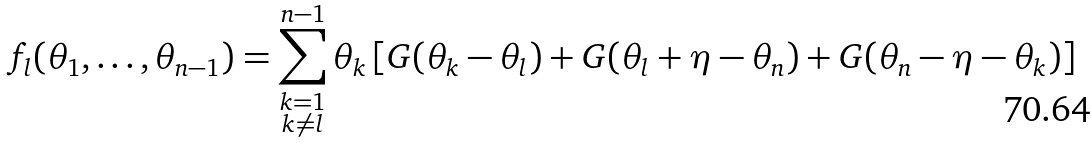<formula> <loc_0><loc_0><loc_500><loc_500>f _ { l } ( \theta _ { 1 } , \dots , \theta _ { n - 1 } ) = \sum _ { \substack { k = 1 \\ k \neq l } } ^ { n - 1 } \theta _ { k } \left [ G ( \theta _ { k } - \theta _ { l } ) + G ( \theta _ { l } + \eta - \theta _ { n } ) + G ( \theta _ { n } - \eta - \theta _ { k } ) \right ]</formula> 